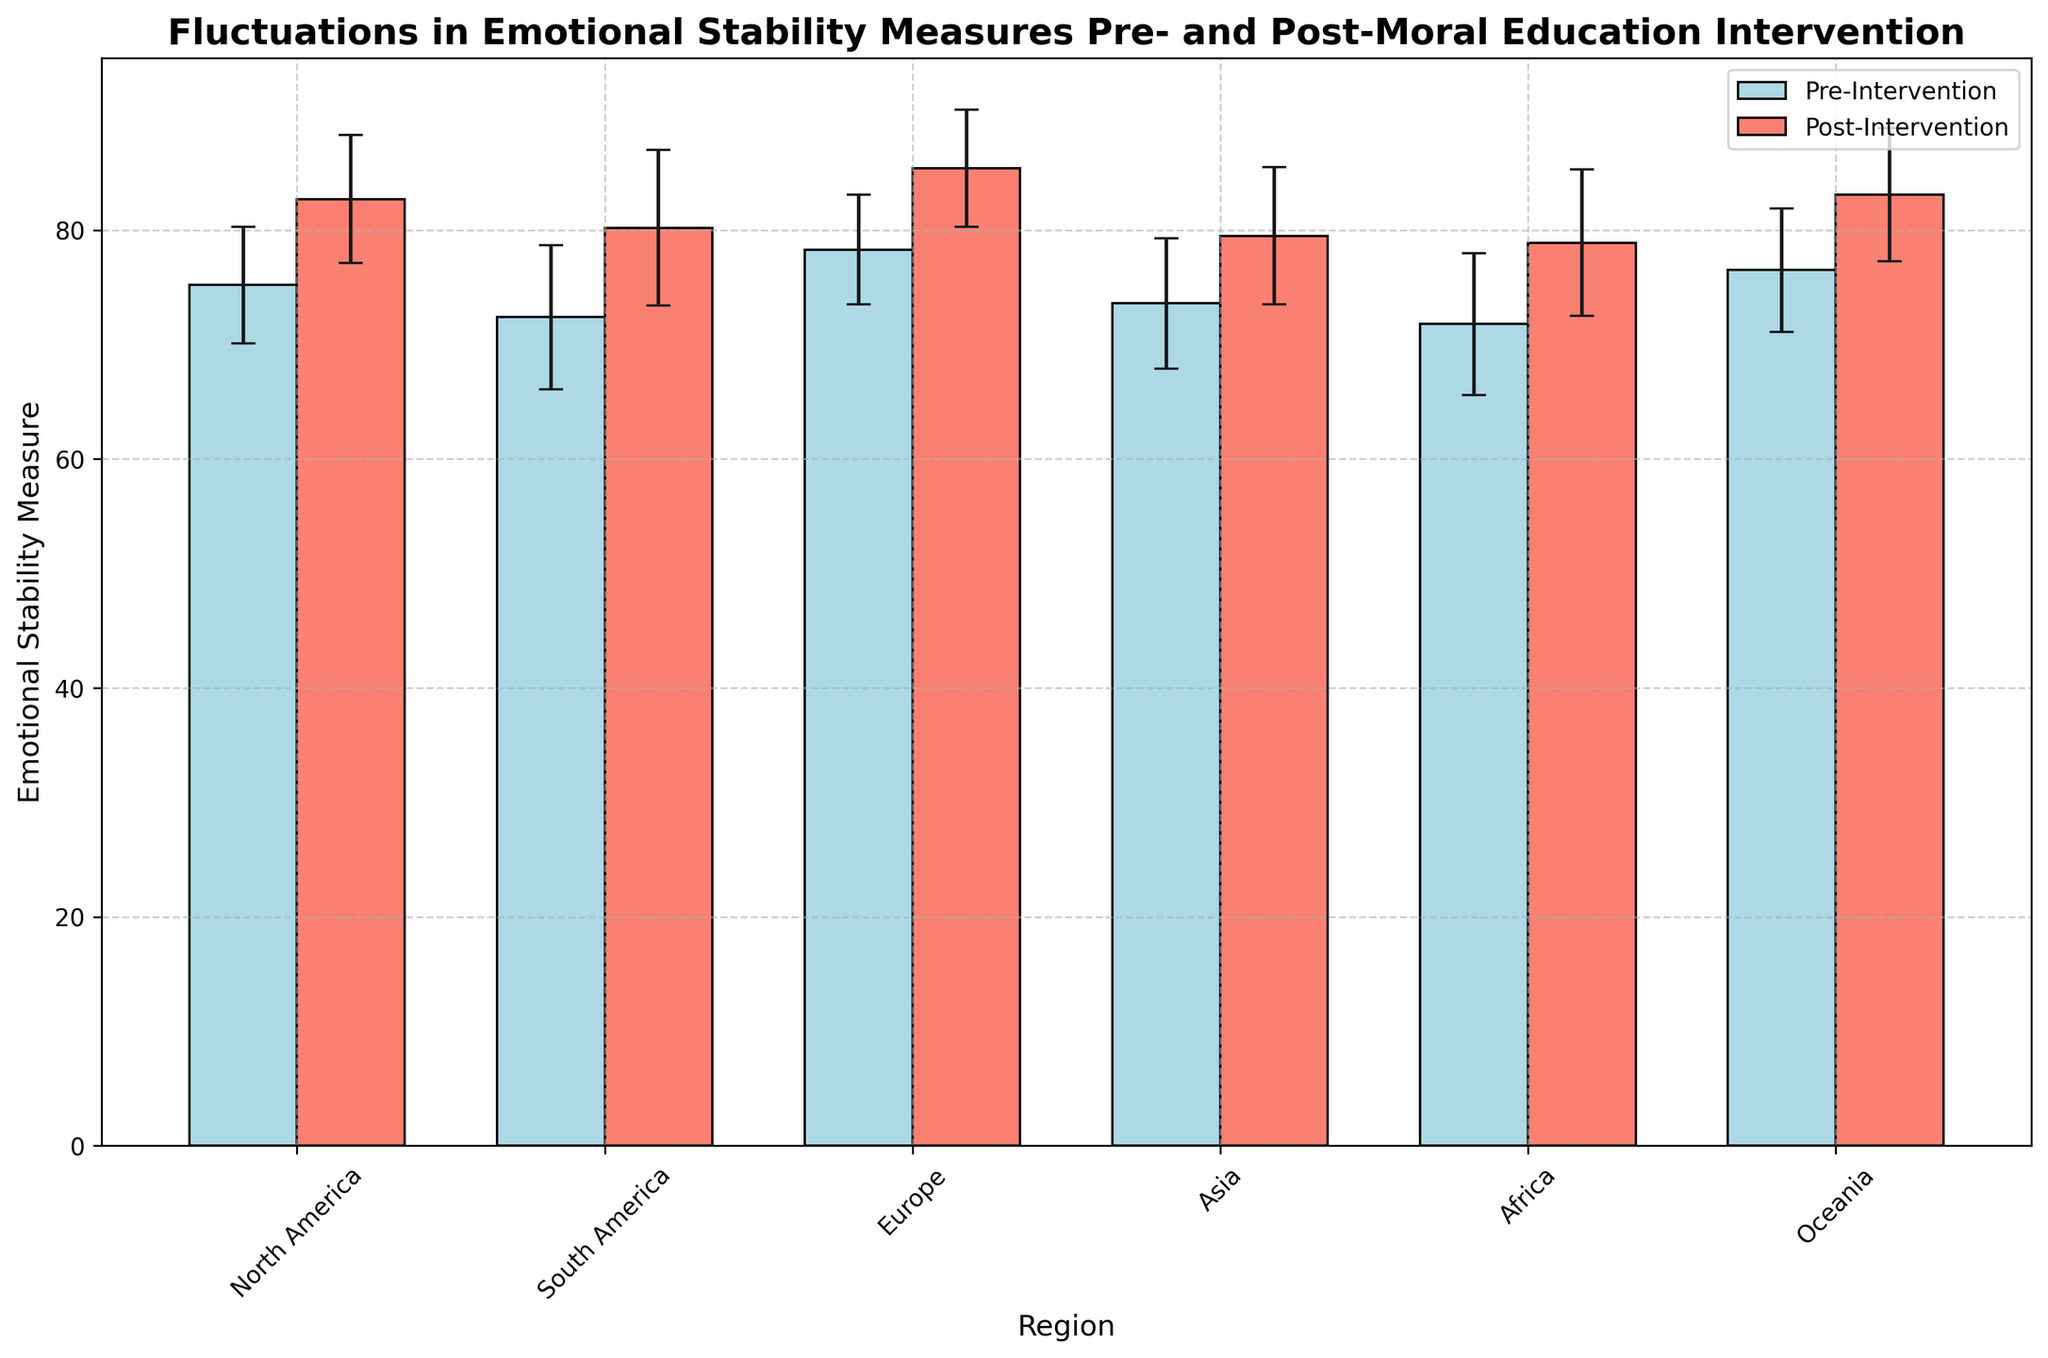Which region shows the greatest improvement in emotional stability post-intervention? Subtract the pre-intervention mean from the post-intervention mean for each region. North America: 82.7 - 75.2 = 7.5, South America: 80.2 - 72.4 = 7.8, Europe: 85.4 - 78.3 = 7.1, Asia: 79.5 - 73.6 = 5.9, Africa: 78.9 - 71.8 = 7.1, Oceania: 83.1 - 76.5 = 6.6. South America has the largest difference of +7.8.
Answer: South America Which region had the highest emotional stability measure after the intervention? Compare the post-intervention means for each region: North America: 82.7, South America: 80.2, Europe: 85.4, Asia: 79.5, Africa: 78.9, Oceania: 83.1. Europe has the highest measure at 85.4.
Answer: Europe What is the average pre-intervention emotional stability measure across all regions? Sum the pre-intervention means and divide by the number of regions: (75.2 + 72.4 + 78.3 + 73.6 + 71.8 + 76.5) / 6 = 447.8 / 6 = 74.63.
Answer: 74.63 Which region has the smallest standard deviation in post-intervention emotional stability? Compare the post-intervention standard deviations for each region: North America: 5.6, South America: 6.8, Europe: 5.1, Asia: 6.0, Africa: 6.4, Oceania: 5.8. Europe has the smallest standard deviation at 5.1.
Answer: Europe Which two regions show the closest pre-intervention emotional stability values? Compare the pre-intervention means: North America: 75.2, South America: 72.4, Europe: 78.3, Asia: 73.6, Africa: 71.8, Oceania: 76.5. North America (75.2) and Oceania (76.5) are closest with a difference of 1.3.
Answer: North America and Oceania What is the difference between the highest and lowest pre-intervention emotional stability measure? Identify the highest and lowest pre-intervention means: highest is Europe at 78.3, and the lowest is Africa at 71.8. Difference: 78.3 - 71.8 = 6.5.
Answer: 6.5 How does the post-intervention standard deviation in South America compare to that in Asia? Compare the post-intervention standard deviations: South America: 6.8, Asia: 6.0. South America's is larger.
Answer: South America's is larger What is the sum of the pre- and post-intervention means for Africa? Sum the pre- and post-intervention means for Africa: 71.8 (pre) + 78.9 (post) = 150.7.
Answer: 150.7 